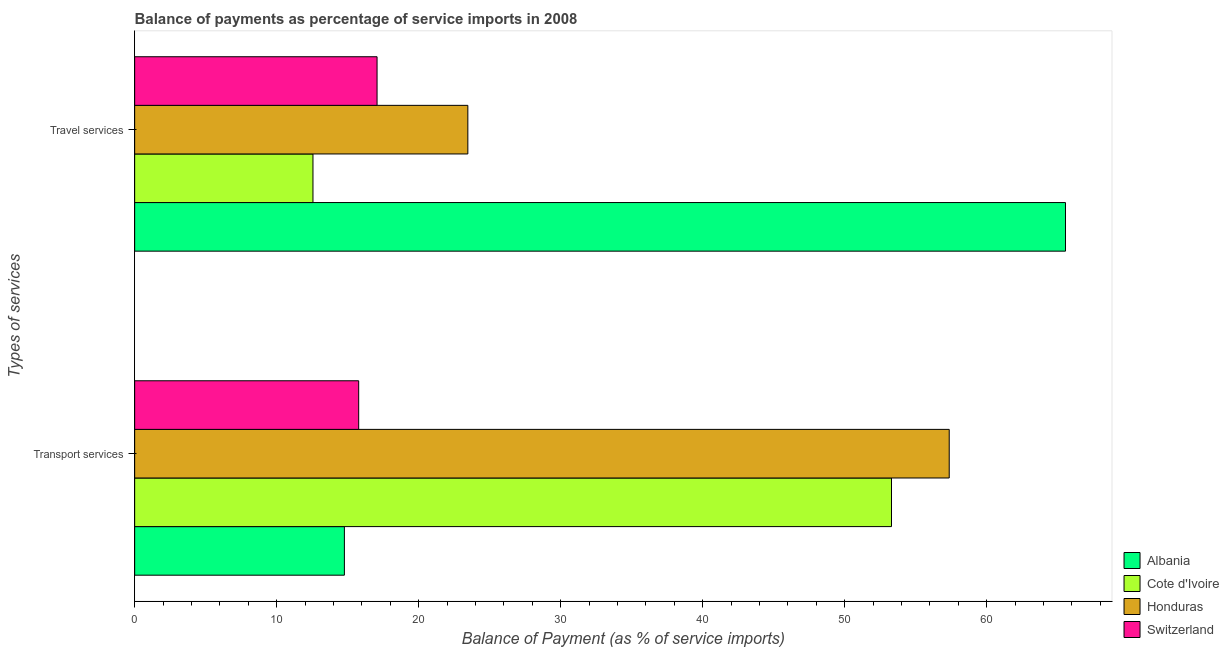How many different coloured bars are there?
Provide a succinct answer. 4. How many groups of bars are there?
Your answer should be compact. 2. Are the number of bars per tick equal to the number of legend labels?
Keep it short and to the point. Yes. How many bars are there on the 2nd tick from the bottom?
Provide a succinct answer. 4. What is the label of the 1st group of bars from the top?
Your answer should be compact. Travel services. What is the balance of payments of travel services in Albania?
Make the answer very short. 65.54. Across all countries, what is the maximum balance of payments of travel services?
Your answer should be very brief. 65.54. Across all countries, what is the minimum balance of payments of transport services?
Ensure brevity in your answer.  14.77. In which country was the balance of payments of travel services maximum?
Give a very brief answer. Albania. In which country was the balance of payments of travel services minimum?
Make the answer very short. Cote d'Ivoire. What is the total balance of payments of transport services in the graph?
Your answer should be very brief. 141.2. What is the difference between the balance of payments of transport services in Honduras and that in Albania?
Your response must be concise. 42.59. What is the difference between the balance of payments of transport services in Albania and the balance of payments of travel services in Cote d'Ivoire?
Provide a short and direct response. 2.21. What is the average balance of payments of transport services per country?
Make the answer very short. 35.3. What is the difference between the balance of payments of transport services and balance of payments of travel services in Cote d'Ivoire?
Make the answer very short. 40.74. In how many countries, is the balance of payments of travel services greater than 44 %?
Offer a very short reply. 1. What is the ratio of the balance of payments of travel services in Honduras to that in Switzerland?
Give a very brief answer. 1.37. What does the 1st bar from the top in Travel services represents?
Keep it short and to the point. Switzerland. What does the 3rd bar from the bottom in Travel services represents?
Offer a very short reply. Honduras. How many countries are there in the graph?
Provide a succinct answer. 4. What is the difference between two consecutive major ticks on the X-axis?
Make the answer very short. 10. Are the values on the major ticks of X-axis written in scientific E-notation?
Give a very brief answer. No. Does the graph contain any zero values?
Your answer should be very brief. No. Does the graph contain grids?
Provide a short and direct response. No. What is the title of the graph?
Offer a very short reply. Balance of payments as percentage of service imports in 2008. Does "Estonia" appear as one of the legend labels in the graph?
Your response must be concise. No. What is the label or title of the X-axis?
Keep it short and to the point. Balance of Payment (as % of service imports). What is the label or title of the Y-axis?
Your answer should be compact. Types of services. What is the Balance of Payment (as % of service imports) of Albania in Transport services?
Your response must be concise. 14.77. What is the Balance of Payment (as % of service imports) of Cote d'Ivoire in Transport services?
Provide a short and direct response. 53.29. What is the Balance of Payment (as % of service imports) of Honduras in Transport services?
Keep it short and to the point. 57.36. What is the Balance of Payment (as % of service imports) in Switzerland in Transport services?
Provide a succinct answer. 15.78. What is the Balance of Payment (as % of service imports) in Albania in Travel services?
Your answer should be compact. 65.54. What is the Balance of Payment (as % of service imports) in Cote d'Ivoire in Travel services?
Offer a very short reply. 12.56. What is the Balance of Payment (as % of service imports) of Honduras in Travel services?
Keep it short and to the point. 23.46. What is the Balance of Payment (as % of service imports) of Switzerland in Travel services?
Offer a terse response. 17.07. Across all Types of services, what is the maximum Balance of Payment (as % of service imports) in Albania?
Your response must be concise. 65.54. Across all Types of services, what is the maximum Balance of Payment (as % of service imports) of Cote d'Ivoire?
Your answer should be compact. 53.29. Across all Types of services, what is the maximum Balance of Payment (as % of service imports) of Honduras?
Give a very brief answer. 57.36. Across all Types of services, what is the maximum Balance of Payment (as % of service imports) of Switzerland?
Give a very brief answer. 17.07. Across all Types of services, what is the minimum Balance of Payment (as % of service imports) in Albania?
Keep it short and to the point. 14.77. Across all Types of services, what is the minimum Balance of Payment (as % of service imports) of Cote d'Ivoire?
Your answer should be very brief. 12.56. Across all Types of services, what is the minimum Balance of Payment (as % of service imports) of Honduras?
Make the answer very short. 23.46. Across all Types of services, what is the minimum Balance of Payment (as % of service imports) in Switzerland?
Offer a very short reply. 15.78. What is the total Balance of Payment (as % of service imports) of Albania in the graph?
Offer a very short reply. 80.31. What is the total Balance of Payment (as % of service imports) in Cote d'Ivoire in the graph?
Your answer should be compact. 65.85. What is the total Balance of Payment (as % of service imports) of Honduras in the graph?
Your answer should be very brief. 80.82. What is the total Balance of Payment (as % of service imports) of Switzerland in the graph?
Provide a succinct answer. 32.85. What is the difference between the Balance of Payment (as % of service imports) of Albania in Transport services and that in Travel services?
Offer a very short reply. -50.78. What is the difference between the Balance of Payment (as % of service imports) in Cote d'Ivoire in Transport services and that in Travel services?
Offer a very short reply. 40.74. What is the difference between the Balance of Payment (as % of service imports) in Honduras in Transport services and that in Travel services?
Ensure brevity in your answer.  33.9. What is the difference between the Balance of Payment (as % of service imports) of Switzerland in Transport services and that in Travel services?
Give a very brief answer. -1.29. What is the difference between the Balance of Payment (as % of service imports) of Albania in Transport services and the Balance of Payment (as % of service imports) of Cote d'Ivoire in Travel services?
Make the answer very short. 2.21. What is the difference between the Balance of Payment (as % of service imports) of Albania in Transport services and the Balance of Payment (as % of service imports) of Honduras in Travel services?
Your response must be concise. -8.69. What is the difference between the Balance of Payment (as % of service imports) of Albania in Transport services and the Balance of Payment (as % of service imports) of Switzerland in Travel services?
Offer a terse response. -2.3. What is the difference between the Balance of Payment (as % of service imports) in Cote d'Ivoire in Transport services and the Balance of Payment (as % of service imports) in Honduras in Travel services?
Make the answer very short. 29.83. What is the difference between the Balance of Payment (as % of service imports) in Cote d'Ivoire in Transport services and the Balance of Payment (as % of service imports) in Switzerland in Travel services?
Make the answer very short. 36.22. What is the difference between the Balance of Payment (as % of service imports) in Honduras in Transport services and the Balance of Payment (as % of service imports) in Switzerland in Travel services?
Your response must be concise. 40.29. What is the average Balance of Payment (as % of service imports) of Albania per Types of services?
Ensure brevity in your answer.  40.16. What is the average Balance of Payment (as % of service imports) in Cote d'Ivoire per Types of services?
Make the answer very short. 32.92. What is the average Balance of Payment (as % of service imports) of Honduras per Types of services?
Give a very brief answer. 40.41. What is the average Balance of Payment (as % of service imports) of Switzerland per Types of services?
Offer a terse response. 16.42. What is the difference between the Balance of Payment (as % of service imports) in Albania and Balance of Payment (as % of service imports) in Cote d'Ivoire in Transport services?
Offer a terse response. -38.52. What is the difference between the Balance of Payment (as % of service imports) of Albania and Balance of Payment (as % of service imports) of Honduras in Transport services?
Give a very brief answer. -42.59. What is the difference between the Balance of Payment (as % of service imports) of Albania and Balance of Payment (as % of service imports) of Switzerland in Transport services?
Give a very brief answer. -1.01. What is the difference between the Balance of Payment (as % of service imports) in Cote d'Ivoire and Balance of Payment (as % of service imports) in Honduras in Transport services?
Give a very brief answer. -4.06. What is the difference between the Balance of Payment (as % of service imports) of Cote d'Ivoire and Balance of Payment (as % of service imports) of Switzerland in Transport services?
Offer a very short reply. 37.52. What is the difference between the Balance of Payment (as % of service imports) of Honduras and Balance of Payment (as % of service imports) of Switzerland in Transport services?
Provide a short and direct response. 41.58. What is the difference between the Balance of Payment (as % of service imports) in Albania and Balance of Payment (as % of service imports) in Cote d'Ivoire in Travel services?
Offer a terse response. 52.99. What is the difference between the Balance of Payment (as % of service imports) in Albania and Balance of Payment (as % of service imports) in Honduras in Travel services?
Your response must be concise. 42.08. What is the difference between the Balance of Payment (as % of service imports) in Albania and Balance of Payment (as % of service imports) in Switzerland in Travel services?
Make the answer very short. 48.48. What is the difference between the Balance of Payment (as % of service imports) of Cote d'Ivoire and Balance of Payment (as % of service imports) of Honduras in Travel services?
Make the answer very short. -10.91. What is the difference between the Balance of Payment (as % of service imports) in Cote d'Ivoire and Balance of Payment (as % of service imports) in Switzerland in Travel services?
Offer a very short reply. -4.51. What is the difference between the Balance of Payment (as % of service imports) in Honduras and Balance of Payment (as % of service imports) in Switzerland in Travel services?
Give a very brief answer. 6.39. What is the ratio of the Balance of Payment (as % of service imports) in Albania in Transport services to that in Travel services?
Provide a succinct answer. 0.23. What is the ratio of the Balance of Payment (as % of service imports) of Cote d'Ivoire in Transport services to that in Travel services?
Provide a succinct answer. 4.24. What is the ratio of the Balance of Payment (as % of service imports) in Honduras in Transport services to that in Travel services?
Your response must be concise. 2.44. What is the ratio of the Balance of Payment (as % of service imports) of Switzerland in Transport services to that in Travel services?
Keep it short and to the point. 0.92. What is the difference between the highest and the second highest Balance of Payment (as % of service imports) of Albania?
Provide a short and direct response. 50.78. What is the difference between the highest and the second highest Balance of Payment (as % of service imports) of Cote d'Ivoire?
Your answer should be very brief. 40.74. What is the difference between the highest and the second highest Balance of Payment (as % of service imports) in Honduras?
Your response must be concise. 33.9. What is the difference between the highest and the second highest Balance of Payment (as % of service imports) of Switzerland?
Your answer should be compact. 1.29. What is the difference between the highest and the lowest Balance of Payment (as % of service imports) of Albania?
Keep it short and to the point. 50.78. What is the difference between the highest and the lowest Balance of Payment (as % of service imports) of Cote d'Ivoire?
Give a very brief answer. 40.74. What is the difference between the highest and the lowest Balance of Payment (as % of service imports) in Honduras?
Offer a terse response. 33.9. What is the difference between the highest and the lowest Balance of Payment (as % of service imports) in Switzerland?
Your answer should be compact. 1.29. 